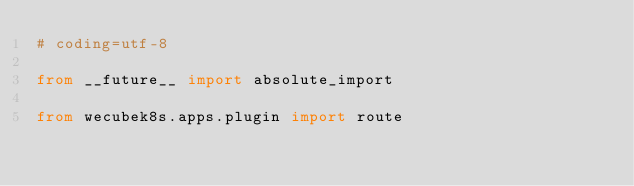<code> <loc_0><loc_0><loc_500><loc_500><_Python_># coding=utf-8

from __future__ import absolute_import

from wecubek8s.apps.plugin import route
</code> 